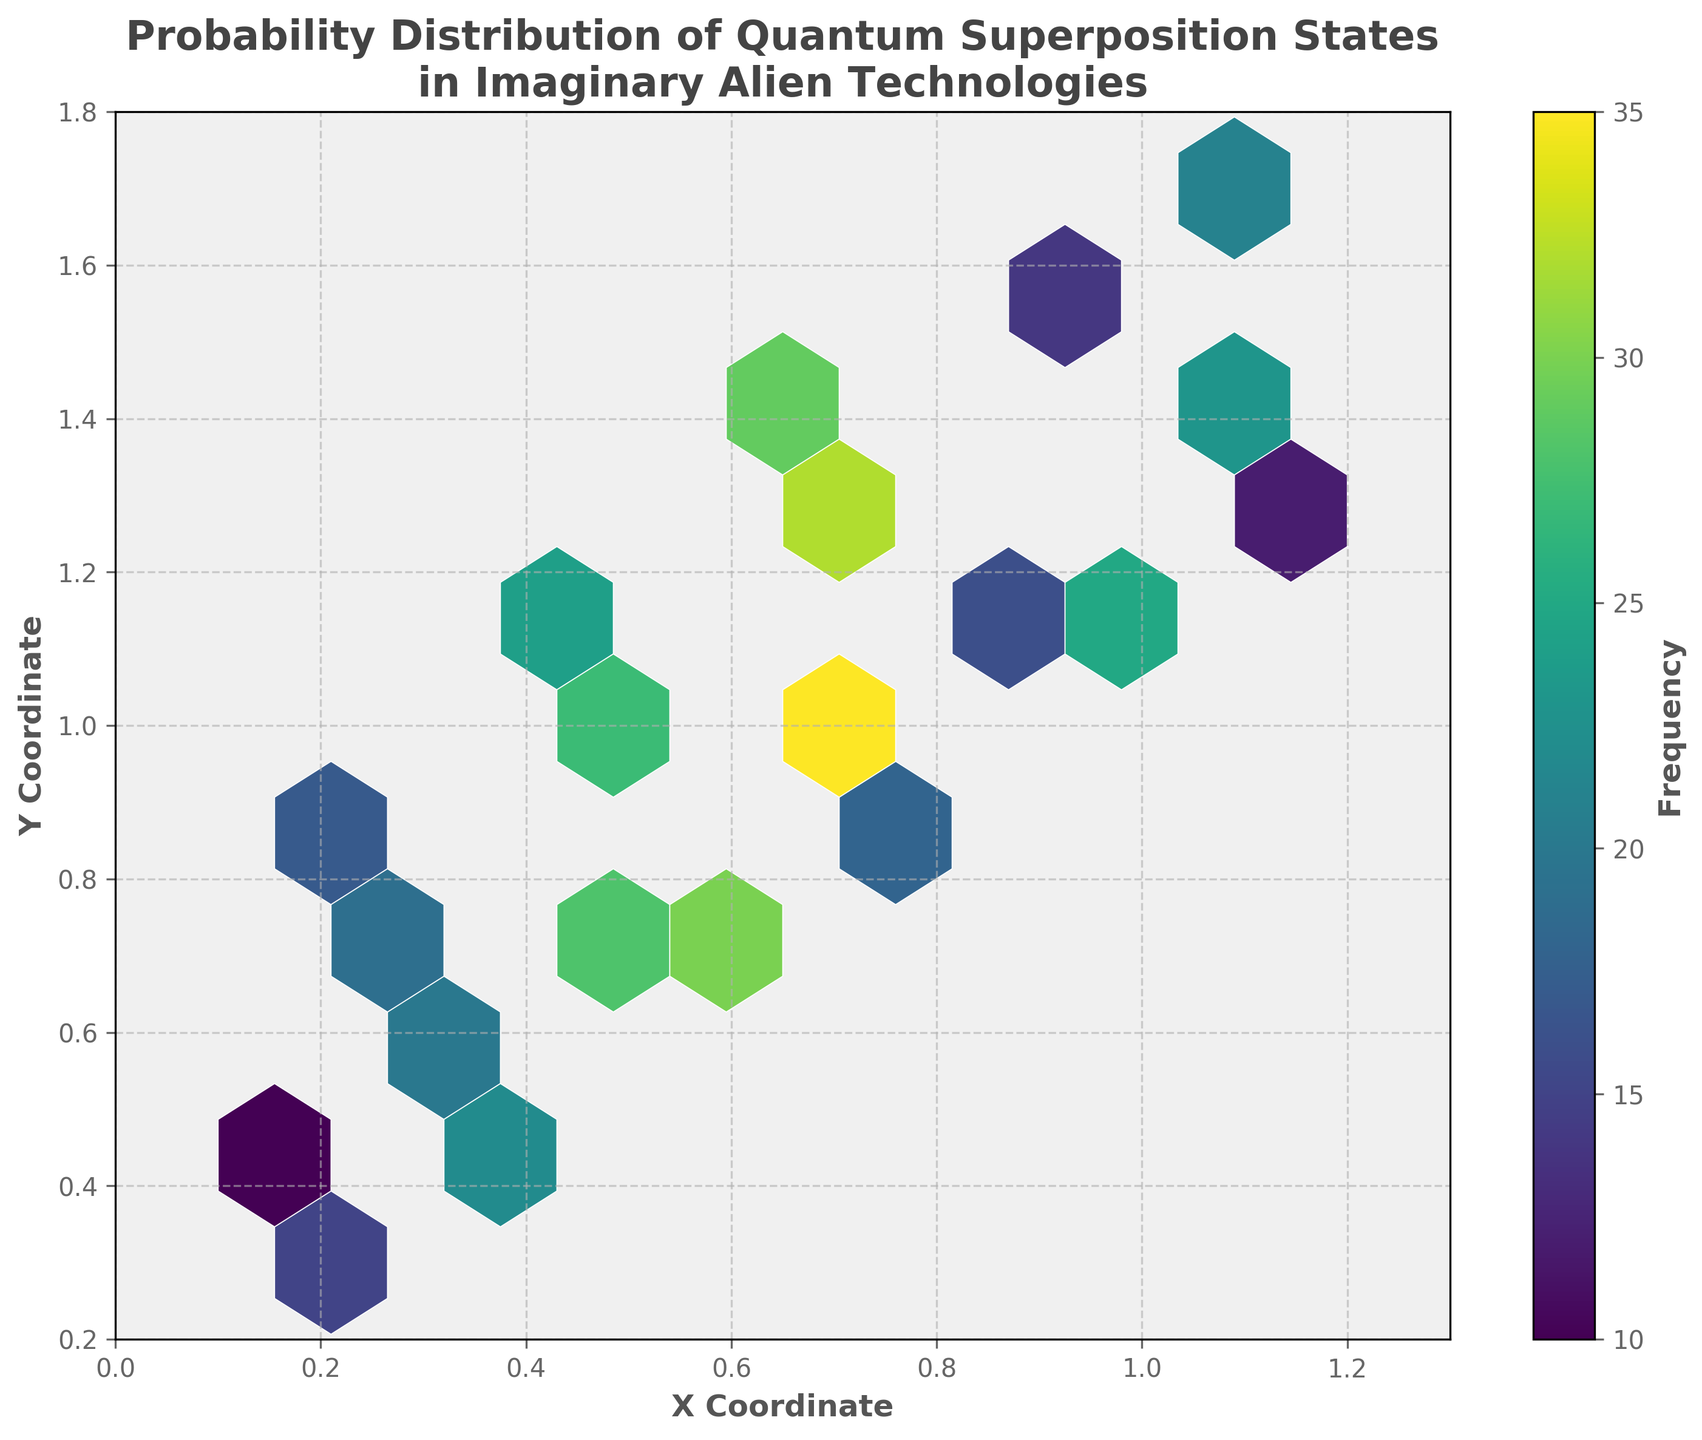What is the title of the figure? The title is located at the top-center of the figure and is usually styled to catch attention, it reads: "Probability Distribution of Quantum Superposition States in Imaginary Alien Technologies"
Answer: Probability Distribution of Quantum Superposition States in Imaginary Alien Technologies What are the labels of the x-axis and y-axis? Typically, axis labels are found along the horizontal and vertical axes. In this figure, the x-axis label is 'X Coordinate' and the y-axis label is 'Y Coordinate'.
Answer: X Coordinate and Y Coordinate Which part of the color spectrum in the hexbin plot represents the highest frequency of quantum superposition states? The color spectrum in the hexbin plot ranges from dark to light. The lightest color (yellowish) indicates the highest frequency, as seen in some of the central hexagons.
Answer: Yellowish color What is the frequency range shown in the color bar? The frequency range is displayed on the color bar, which lies beside the plot. It starts at the lowest value shown and ends at the highest value.
Answer: 10 to 35 How many hexagons are plotted in the hexbin plot? Count the visible hexagons within the plotted area on the figure. Each hexagon represents a bin of data points.
Answer: 20 Which coordinate region has the highest density of quantum superposition states? The highest density region can be identified by locating the hexagon with the brightest color, indicating the highest frequency. This region is around x=0.7, y=1.0
Answer: Around x=0.7 and y=1.0 Is there a higher frequency of quantum superposition states at lower x-coordinates (0.2 to 0.5) compared to higher x-coordinates (0.8 to 1.2)? To answer, compare the number and color intensity of the hexagons in the mentioned x-coordinate ranges. Observe which range has more high-frequency hexagons.
Answer: Yes, higher frequency at higher x-coordinates (0.8 to 1.2) Between x=0.4, y=0.5 and x=1.2, y=1.3, which coordinate has a higher frequency? Compare the frequency values represented by the color intensity of the hexagons at these coordinates.
Answer: x=0.4, y=0.5 Is the distribution of the frequencies in the hexbin plot more concentrated or spread out? Observe the pattern of the hexbin plot, determining whether the higher frequency areas are centralized or dispersed across the plot.
Answer: Concentrated What can be inferred about the relationship between x and y coordinates in terms of frequency? Analyze whether there is a trend in frequency changes along the x and y coordinates, such as whether higher x-coordinates correlate with higher y-coordinates and higher frequencies.
Answer: Higher x-coordinates and y-coordinates tend to have higher frequencies 